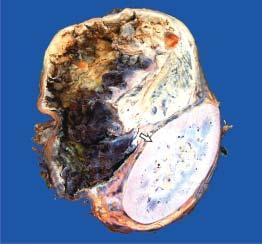what do solid areas show?
Answer the question using a single word or phrase. Dark brown 